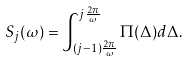<formula> <loc_0><loc_0><loc_500><loc_500>S _ { j } ( \omega ) = \int _ { ( j - 1 ) \frac { 2 \pi } { \omega } } ^ { j \frac { 2 \pi } { \omega } } \Pi ( \Delta ) d \Delta .</formula> 